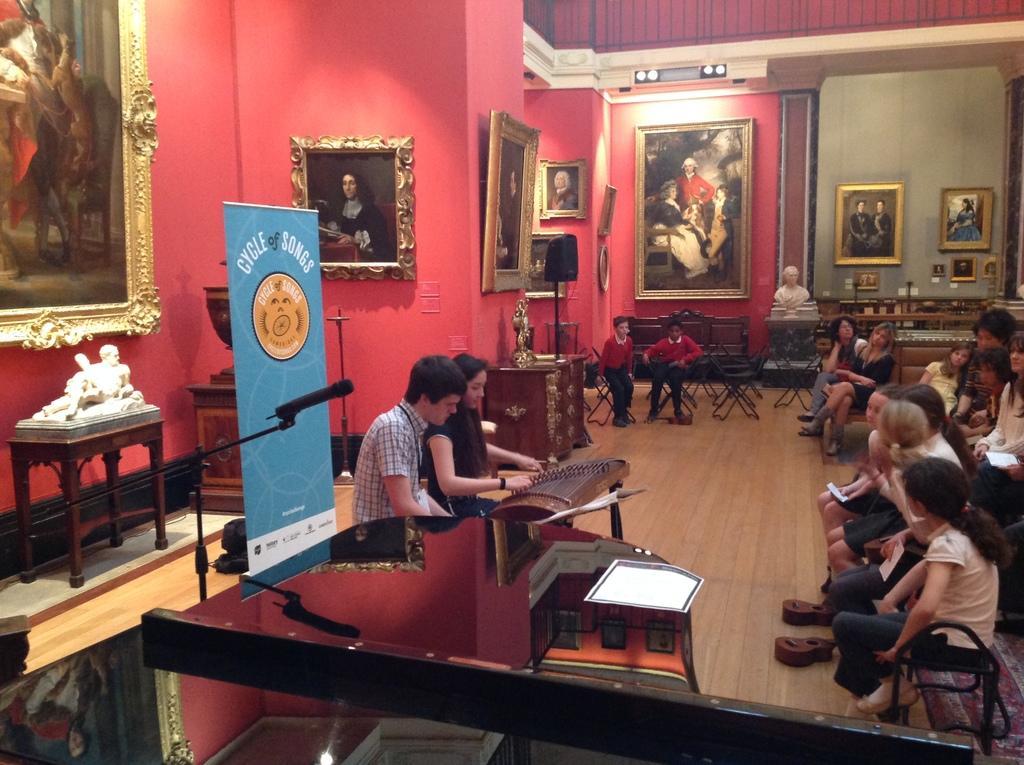Could you give a brief overview of what you see in this image? There are two people sitting and woman is playing musical instrument. On the right few people are sitting on the chair and looking at them. There are frames,hoardings all over the wall. There is a statue on the table. 